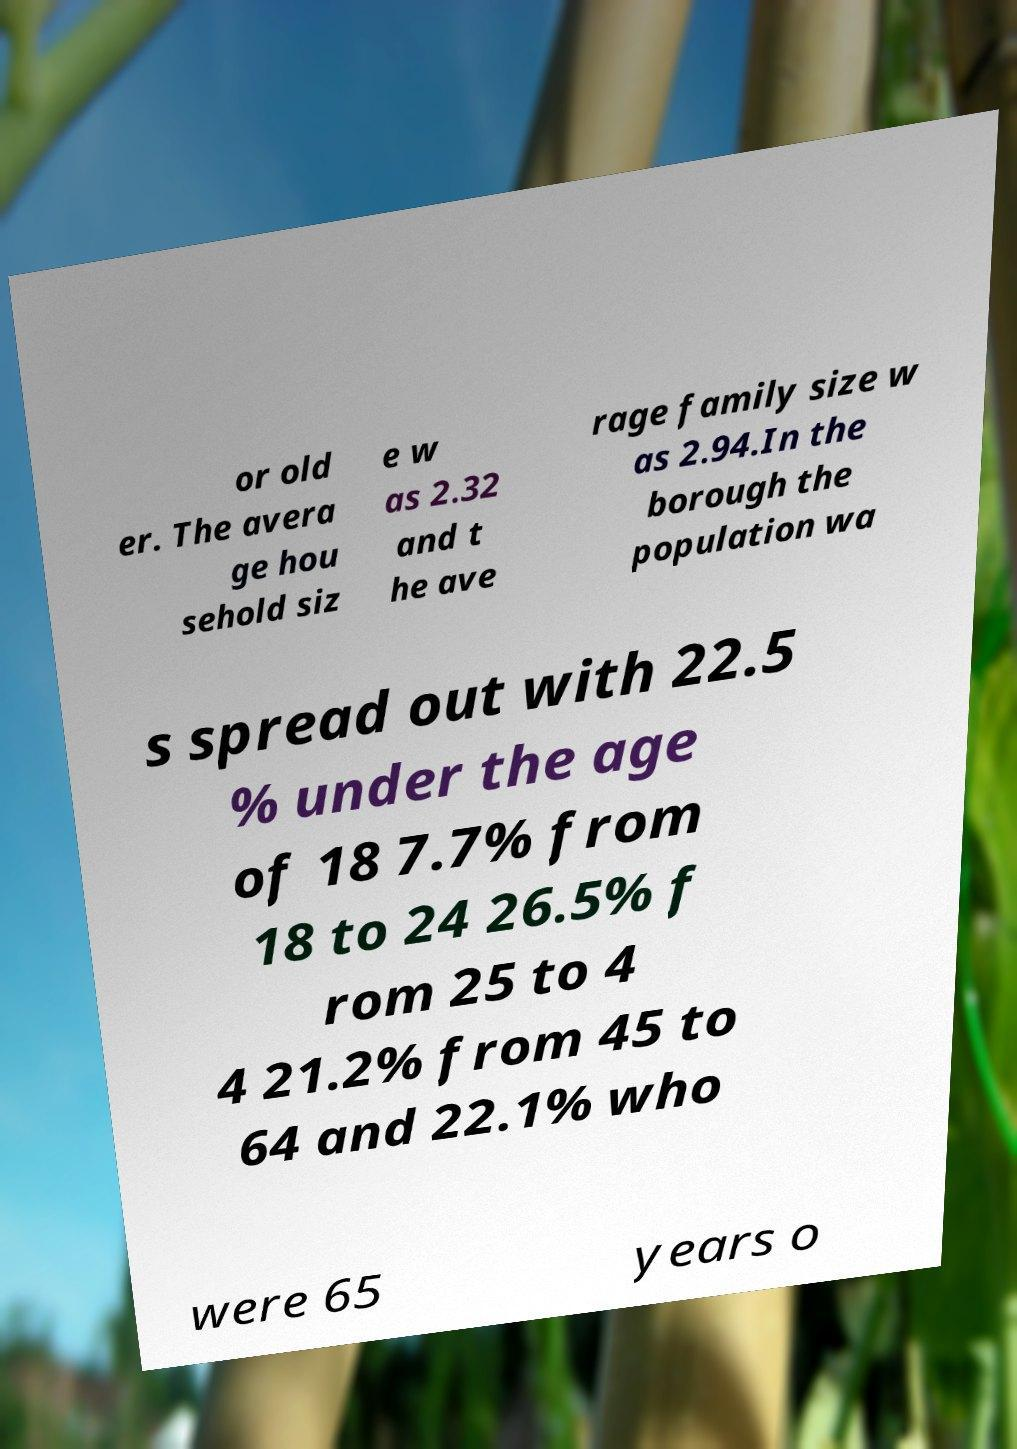For documentation purposes, I need the text within this image transcribed. Could you provide that? or old er. The avera ge hou sehold siz e w as 2.32 and t he ave rage family size w as 2.94.In the borough the population wa s spread out with 22.5 % under the age of 18 7.7% from 18 to 24 26.5% f rom 25 to 4 4 21.2% from 45 to 64 and 22.1% who were 65 years o 